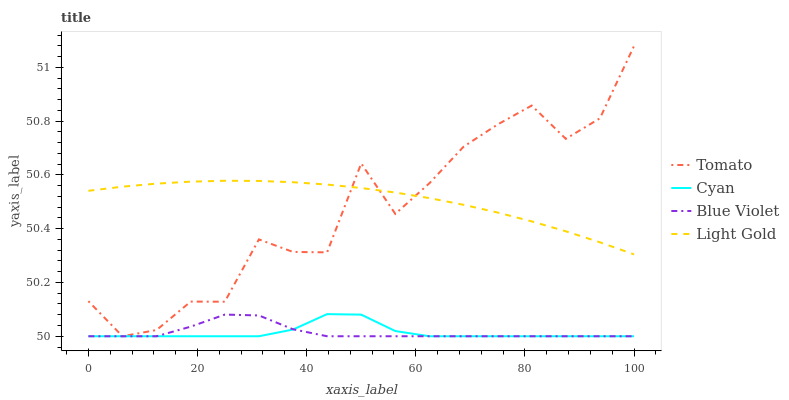Does Cyan have the minimum area under the curve?
Answer yes or no. Yes. Does Light Gold have the maximum area under the curve?
Answer yes or no. Yes. Does Light Gold have the minimum area under the curve?
Answer yes or no. No. Does Cyan have the maximum area under the curve?
Answer yes or no. No. Is Light Gold the smoothest?
Answer yes or no. Yes. Is Tomato the roughest?
Answer yes or no. Yes. Is Cyan the smoothest?
Answer yes or no. No. Is Cyan the roughest?
Answer yes or no. No. Does Tomato have the lowest value?
Answer yes or no. Yes. Does Light Gold have the lowest value?
Answer yes or no. No. Does Tomato have the highest value?
Answer yes or no. Yes. Does Cyan have the highest value?
Answer yes or no. No. Is Cyan less than Light Gold?
Answer yes or no. Yes. Is Light Gold greater than Cyan?
Answer yes or no. Yes. Does Tomato intersect Light Gold?
Answer yes or no. Yes. Is Tomato less than Light Gold?
Answer yes or no. No. Is Tomato greater than Light Gold?
Answer yes or no. No. Does Cyan intersect Light Gold?
Answer yes or no. No. 